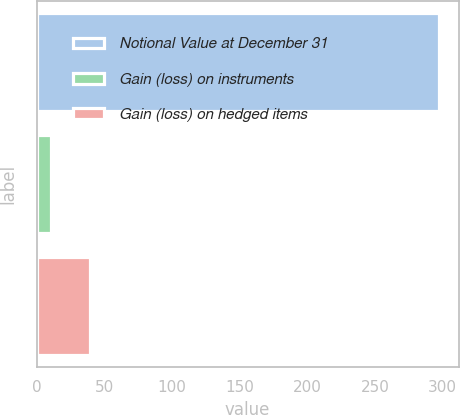Convert chart. <chart><loc_0><loc_0><loc_500><loc_500><bar_chart><fcel>Notional Value at December 31<fcel>Gain (loss) on instruments<fcel>Gain (loss) on hedged items<nl><fcel>297<fcel>11<fcel>39.6<nl></chart> 